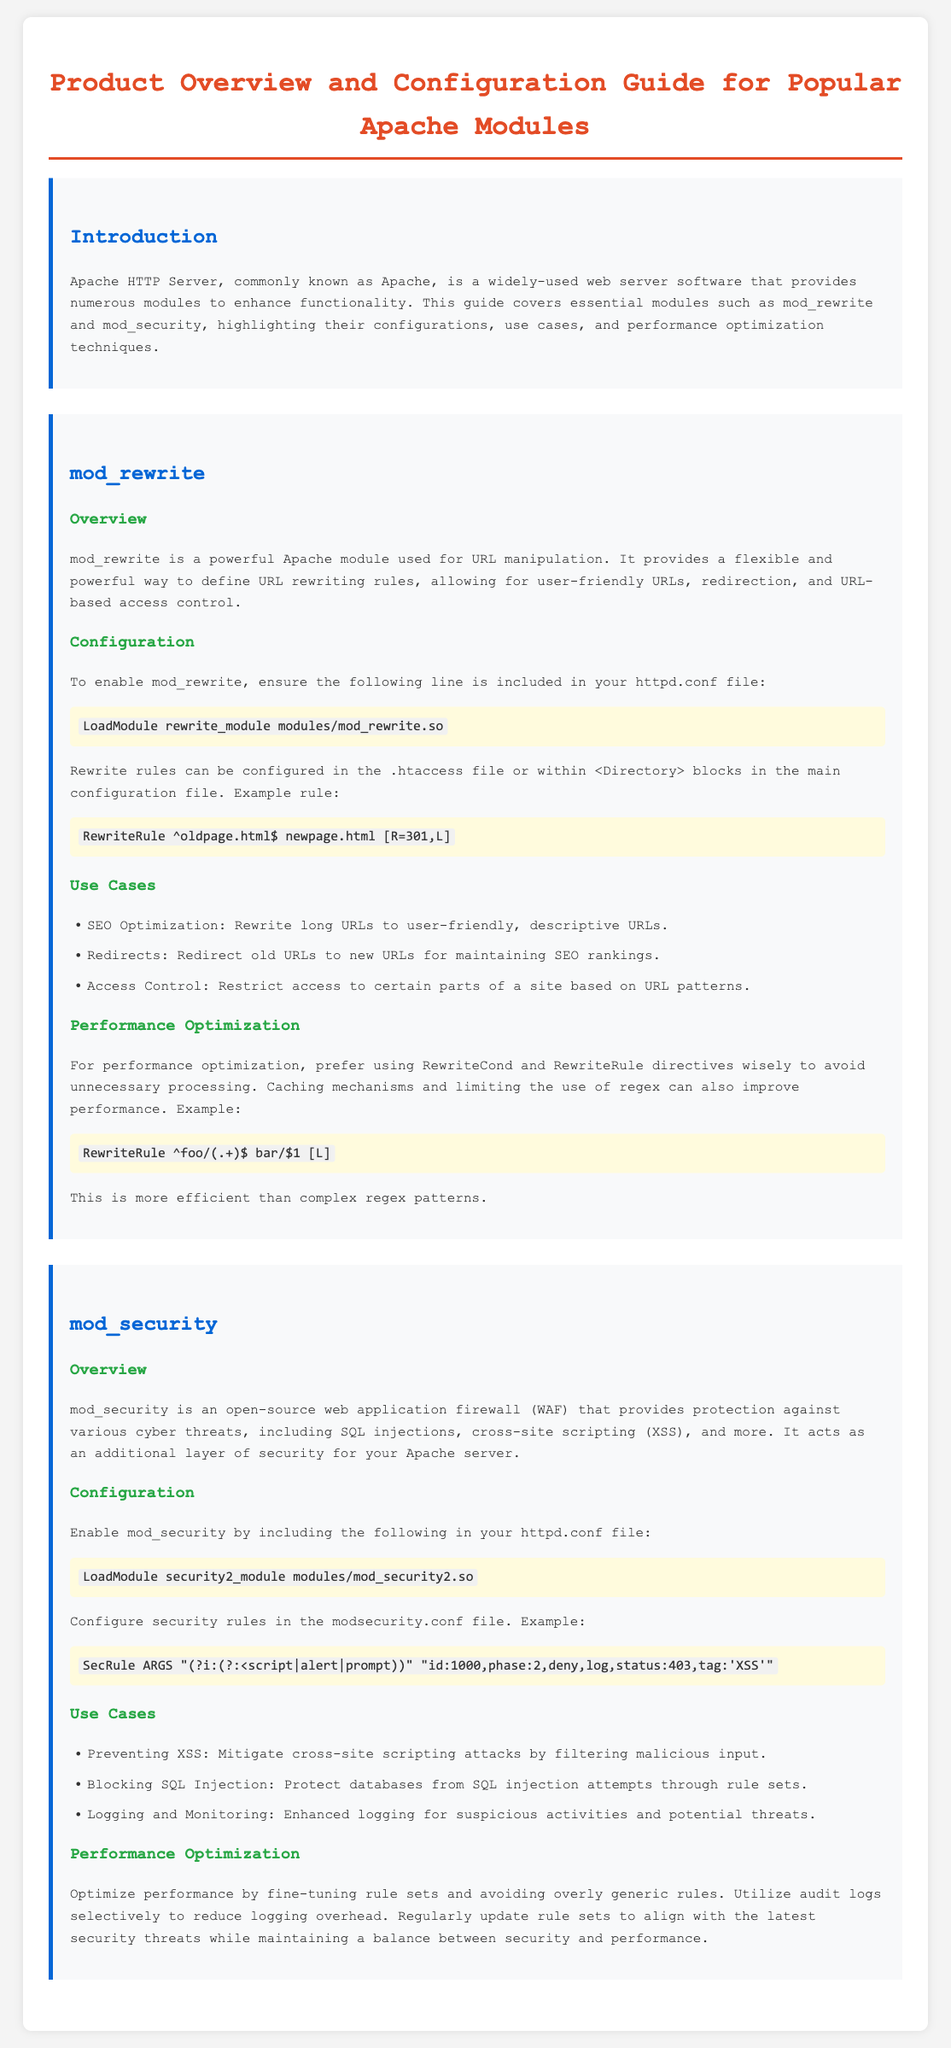What is the primary purpose of mod_rewrite? The primary purpose of mod_rewrite is URL manipulation, providing a way to define URL rewriting rules.
Answer: URL manipulation What line must be included in the httpd.conf file to enable mod_security? The line required to enable mod_security is specified in the configuration section of the document, which is to load the security module.
Answer: LoadModule security2_module modules/mod_security2.so List a use case for mod_security. The use cases for mod_security include protecting against specific cyber threats, which are detailed in the document.
Answer: Preventing XSS What does the example RewriteRule in mod_rewrite do? The example RewriteRule demonstrates how to perform a permanent redirect from one page to another using a specific pattern.
Answer: Redirects old URLs to new URLs Which performance optimization technique is suggested for mod_rewrite? The document provides specific performance optimization suggestions for mod_rewrite, focusing on efficient directive usage.
Answer: Avoid unnecessary processing What type of application does mod_security act as? The document describes mod_security as acting as an additional layer to defend against specific security threats on a web server.
Answer: Web application firewall How does mod_rewrite contribute to SEO? The document indicates that mod_rewrite can modify URLs to be more descriptive and user-friendly, thus aiding search engine optimization.
Answer: SEO Optimization What is the id number in the example SecRule for mod_security? The example SecRule presented in the document contains a specific identification number for tracking the rule's application.
Answer: 1000 Which directive in mod_rewrite is mentioned for better performance? To enhance performance, a specific directive usage in mod_rewrite is highlighted in the performance optimization section.
Answer: RewriteRule 